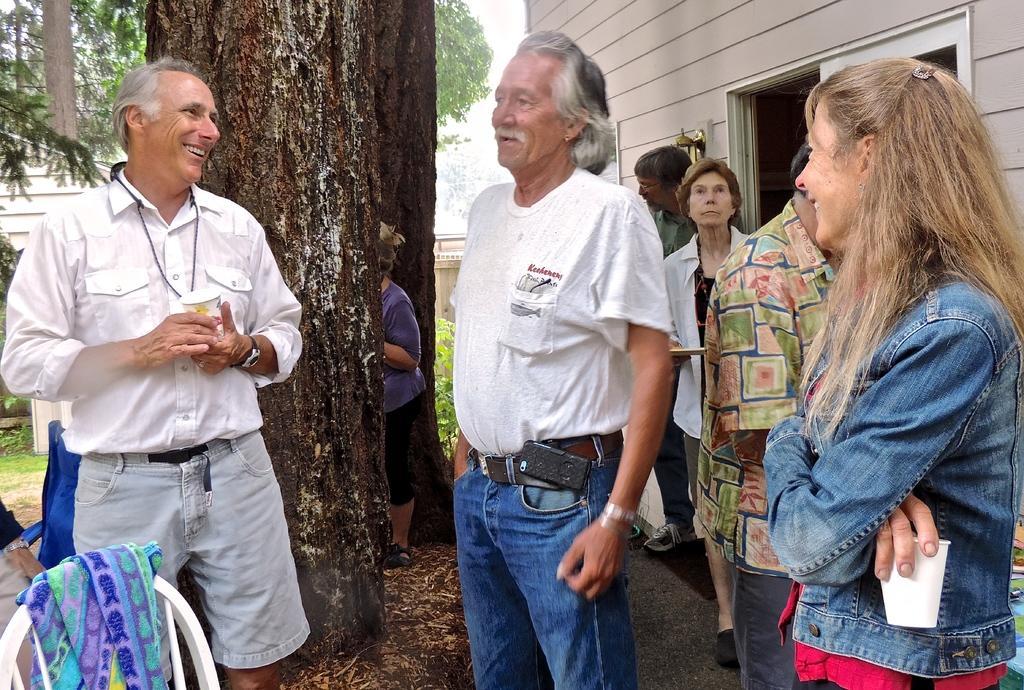In one or two sentences, can you explain what this image depicts? In this image I can see group of people standing. In front the person is wearing white shirt and blue pant. In the background I can see few trees in green color and the sky is in white color. 